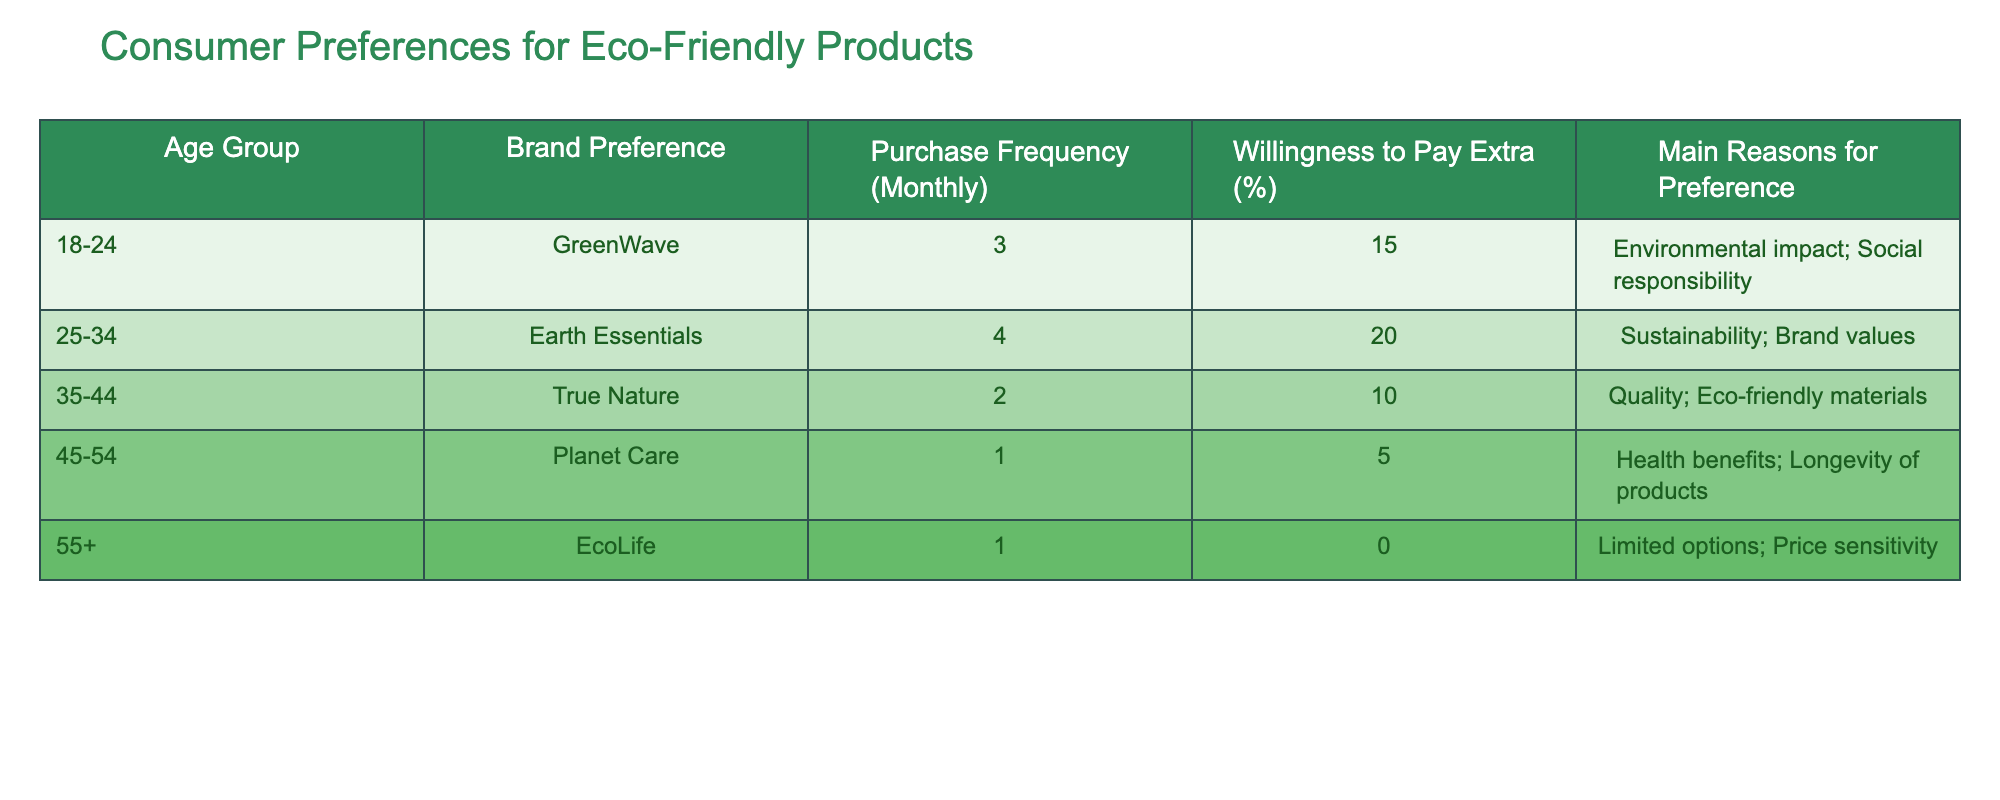What is the brand preference for the age group 35-44? The age group 35-44 prefers the brand True Nature, as indicated in the table.
Answer: True Nature Which age group has the highest willingness to pay extra for eco-friendly products? The age group 25-34 has the highest willingness to pay extra at 20%, as shown in the table.
Answer: 25-34 What is the purchase frequency per month for the age group 18-24? The purchase frequency for the age group 18-24 is 3 times per month, directly taken from the table.
Answer: 3 Is the willingness to pay extra for eco-friendly products higher in the 45-54 age group compared to the 55+ age group? Yes, the 45-54 age group has a willingness to pay extra of 5%, while the 55+ age group has 0%. This indicates that the former is higher.
Answer: Yes What is the average purchase frequency across all age groups? The total purchase frequency is \(3 + 4 + 2 + 1 + 1 = 11\), and there are 5 age groups, so the average is \(11/5 = 2.2\).
Answer: 2.2 Which main reason for brand preference is cited by the 25-34 age group? The main reasons for brand preference in the 25-34 age group are sustainability and brand values, specified in the table.
Answer: Sustainability; Brand values Do more age groups prefer brands that emphasize social responsibility over those that focus on health benefits? Yes, the age groups 18-24 and 25-34 emphasize social responsibility (GreenWave and Earth Essentials), compared to only one group (45-54) that emphasizes health benefits (Planet Care).
Answer: Yes How many age groups have a purchase frequency of 1 per month? Two age groups have a purchase frequency of 1: 45-54 and 55+, as shown in the table.
Answer: 2 What is the difference in willingness to pay extra between the 25-34 and 35-44 age groups? The 25-34 age group's willingness to pay is 20%, while the 35-44 age group's is 10%. Thus, the difference is \(20 - 10 = 10\) percentage points.
Answer: 10 